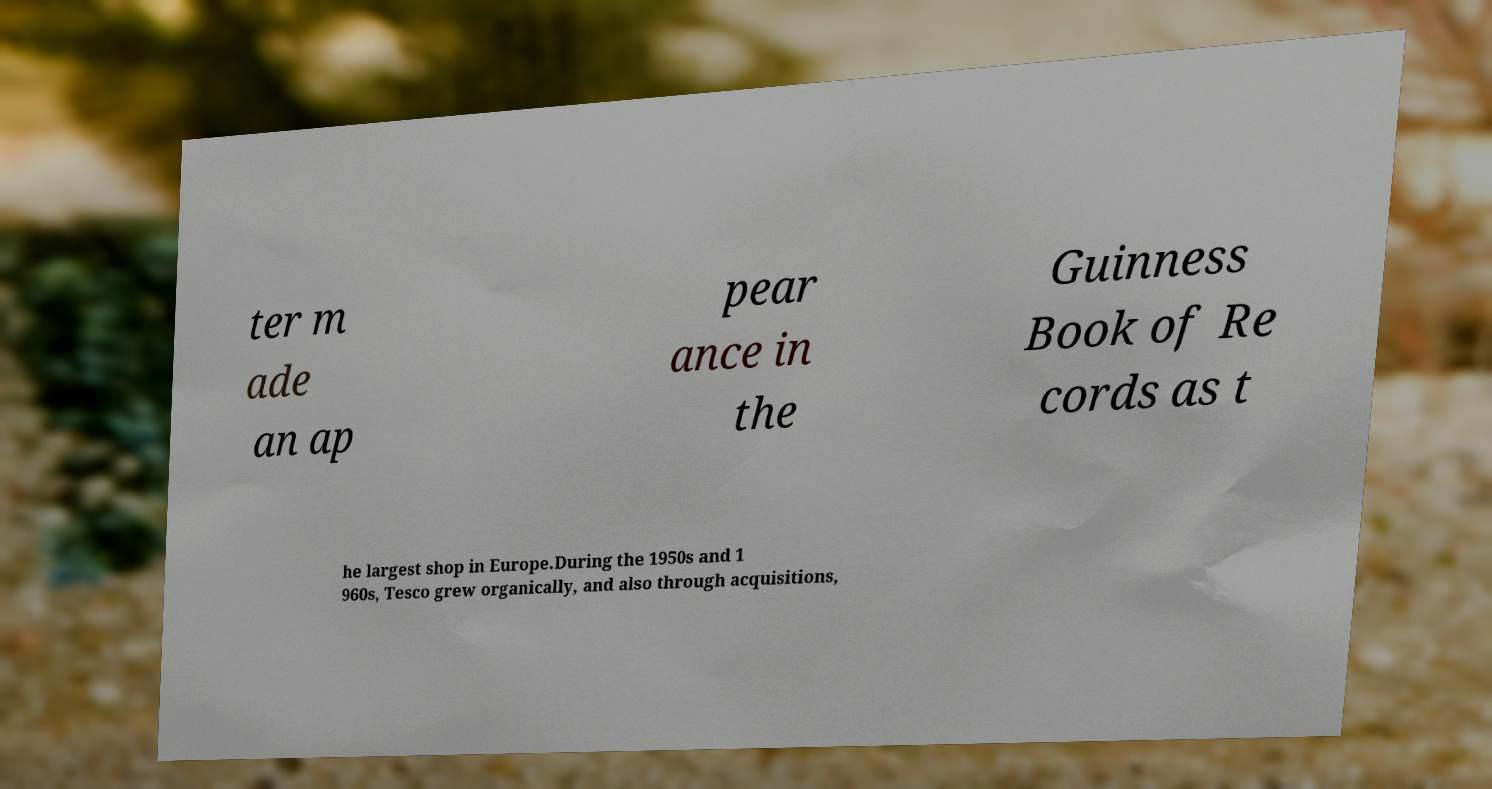For documentation purposes, I need the text within this image transcribed. Could you provide that? ter m ade an ap pear ance in the Guinness Book of Re cords as t he largest shop in Europe.During the 1950s and 1 960s, Tesco grew organically, and also through acquisitions, 